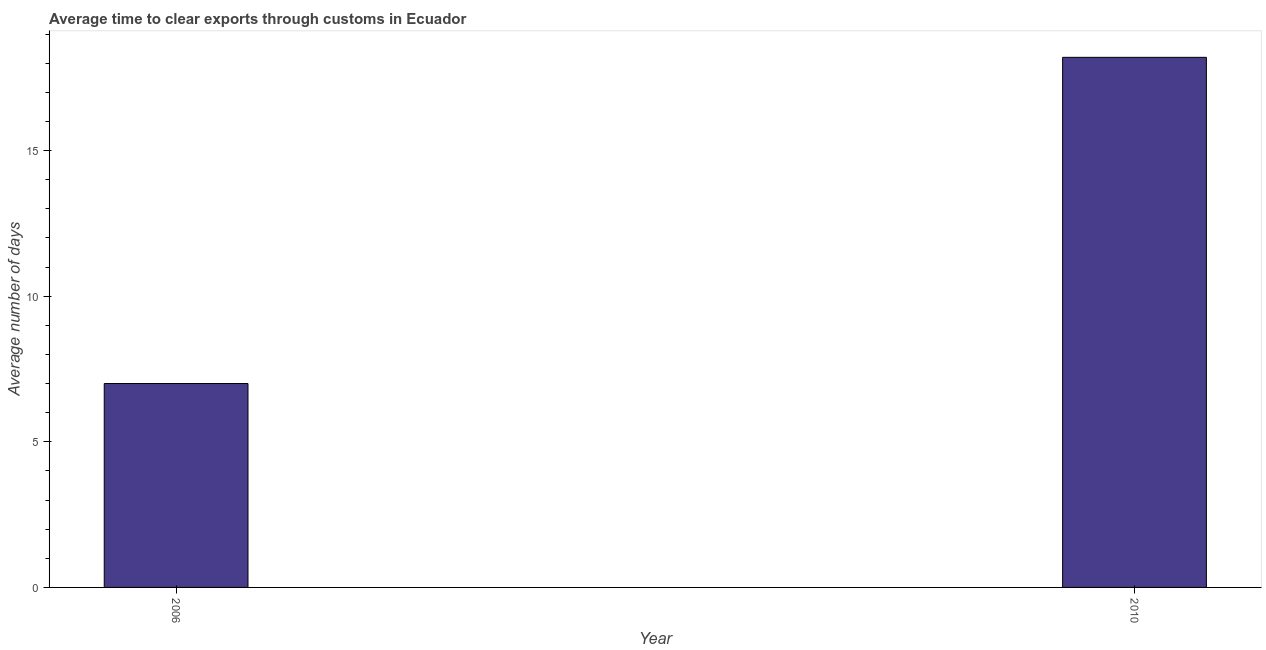Does the graph contain any zero values?
Ensure brevity in your answer.  No. What is the title of the graph?
Give a very brief answer. Average time to clear exports through customs in Ecuador. What is the label or title of the X-axis?
Your answer should be very brief. Year. What is the label or title of the Y-axis?
Provide a succinct answer. Average number of days. Across all years, what is the maximum time to clear exports through customs?
Make the answer very short. 18.2. In which year was the time to clear exports through customs maximum?
Give a very brief answer. 2010. In which year was the time to clear exports through customs minimum?
Offer a very short reply. 2006. What is the sum of the time to clear exports through customs?
Offer a terse response. 25.2. What is the difference between the time to clear exports through customs in 2006 and 2010?
Offer a very short reply. -11.2. What is the ratio of the time to clear exports through customs in 2006 to that in 2010?
Your answer should be very brief. 0.39. Is the time to clear exports through customs in 2006 less than that in 2010?
Your response must be concise. Yes. In how many years, is the time to clear exports through customs greater than the average time to clear exports through customs taken over all years?
Give a very brief answer. 1. Are all the bars in the graph horizontal?
Your answer should be very brief. No. How many years are there in the graph?
Provide a short and direct response. 2. What is the difference between two consecutive major ticks on the Y-axis?
Give a very brief answer. 5. What is the ratio of the Average number of days in 2006 to that in 2010?
Keep it short and to the point. 0.39. 